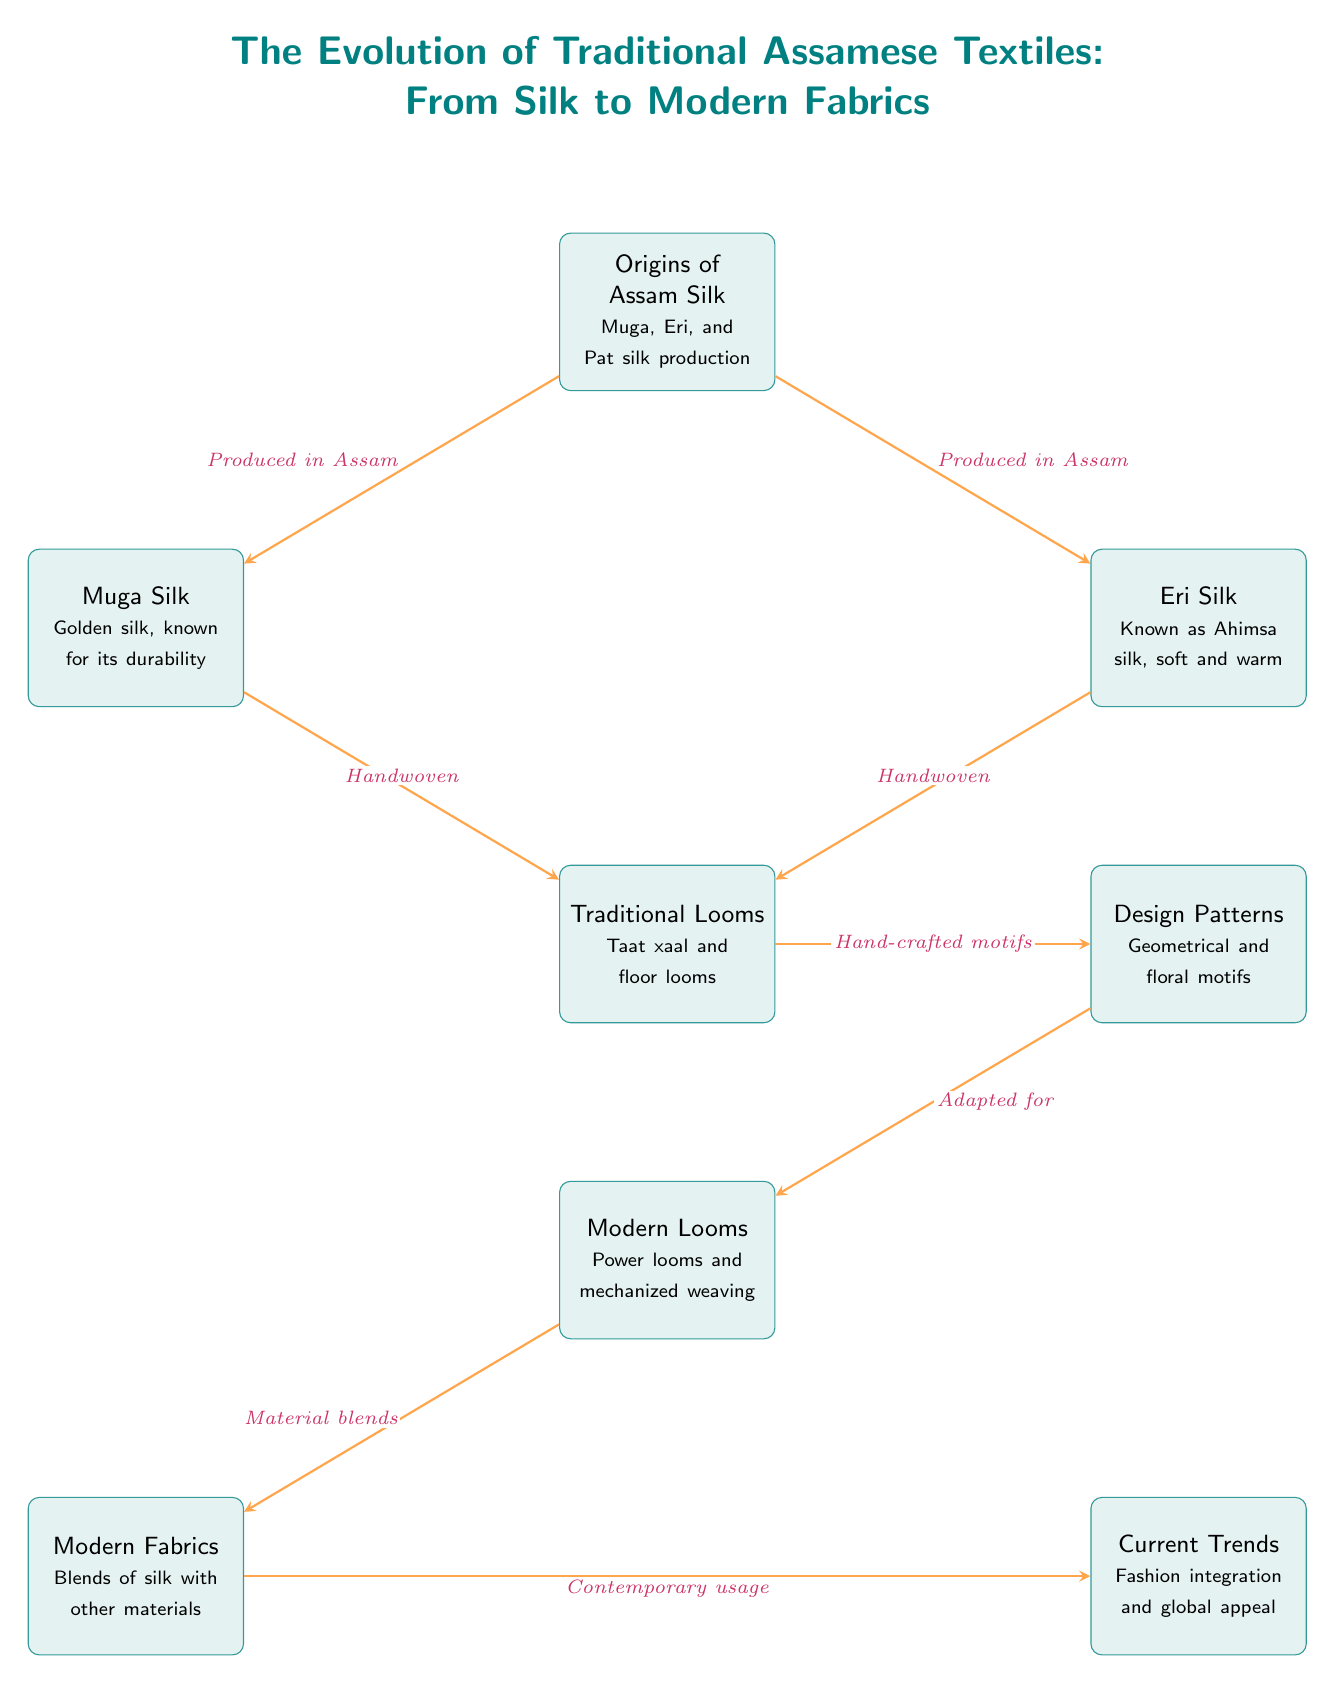What are the three types of silk produced in Assam? The diagram specifically mentions three types of silk under the "Origins of Assam Silk" node: Muga, Eri, and Pat silk.
Answer: Muga, Eri, and Pat silk Which silk is known for its durability? The diagram indicates that Muga silk is described as "Golden silk, known for its durability" directly under the Muga node.
Answer: Muga silk How are Muga and Eri silk primarily produced? Both Muga and Eri silk nodes connect to the "Traditional Looms" node with the label "Handwoven," suggesting that both types are produced using hand weaving techniques.
Answer: Handwoven What weaving techniques are used in the creation of traditional Assamese textiles? The diagram lists "Traditional Looms" and "Modern Looms" as two distinct types, which indicates that both traditional hand looms and modern mechanized looms are used in various stages of textile production.
Answer: Traditional and Modern Looms What design patterns are mentioned in the diagram? The "Design Patterns" node specifies that they consist of "Geometrical and floral motifs." This was taken from the description under the design node.
Answer: Geometrical and floral motifs How do traditional designs evolve in modern Assamese textiles? The flow from "Design Patterns" to "Modern Looms" marked with "Adapted for" indicates that the traditional designs have been adapted for use with modern looms.
Answer: Adapted for modern looms What fabric blends are used in modern Assamese textiles? The diagram specifies that "Modern Fabrics" refer to blends of silk with other materials, emphasizing a shift in fabric composition.
Answer: Blends of silk with other materials What is the influence of modern fabrics on current trends? The "Current Trends" node connects to "Modern Fabrics" with "Contemporary usage," indicating that the use of modern fabrics directly affects prevailing trends in Assamese textiles.
Answer: Contemporary usage 